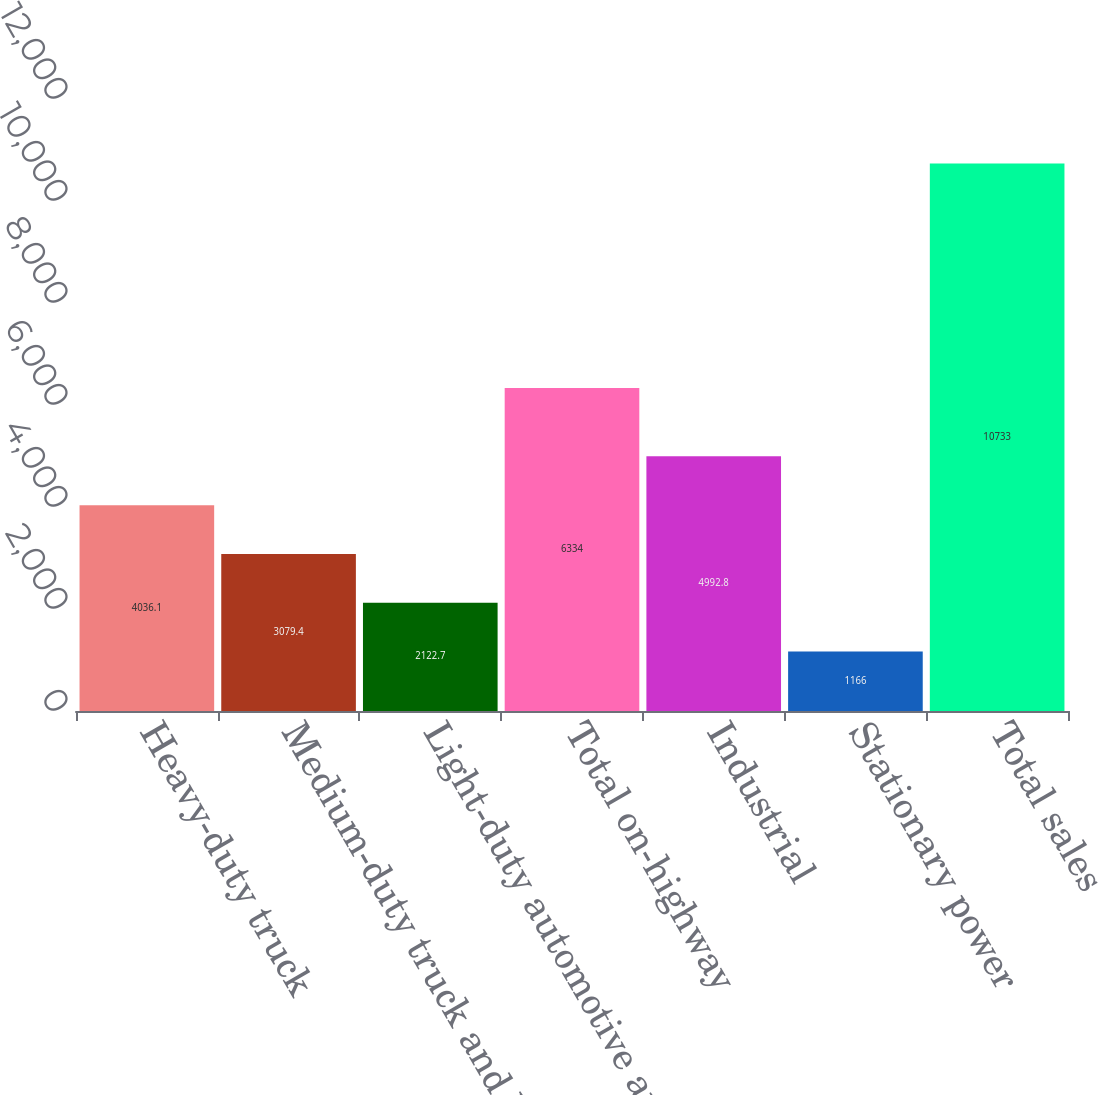<chart> <loc_0><loc_0><loc_500><loc_500><bar_chart><fcel>Heavy-duty truck<fcel>Medium-duty truck and bus<fcel>Light-duty automotive and RV<fcel>Total on-highway<fcel>Industrial<fcel>Stationary power<fcel>Total sales<nl><fcel>4036.1<fcel>3079.4<fcel>2122.7<fcel>6334<fcel>4992.8<fcel>1166<fcel>10733<nl></chart> 